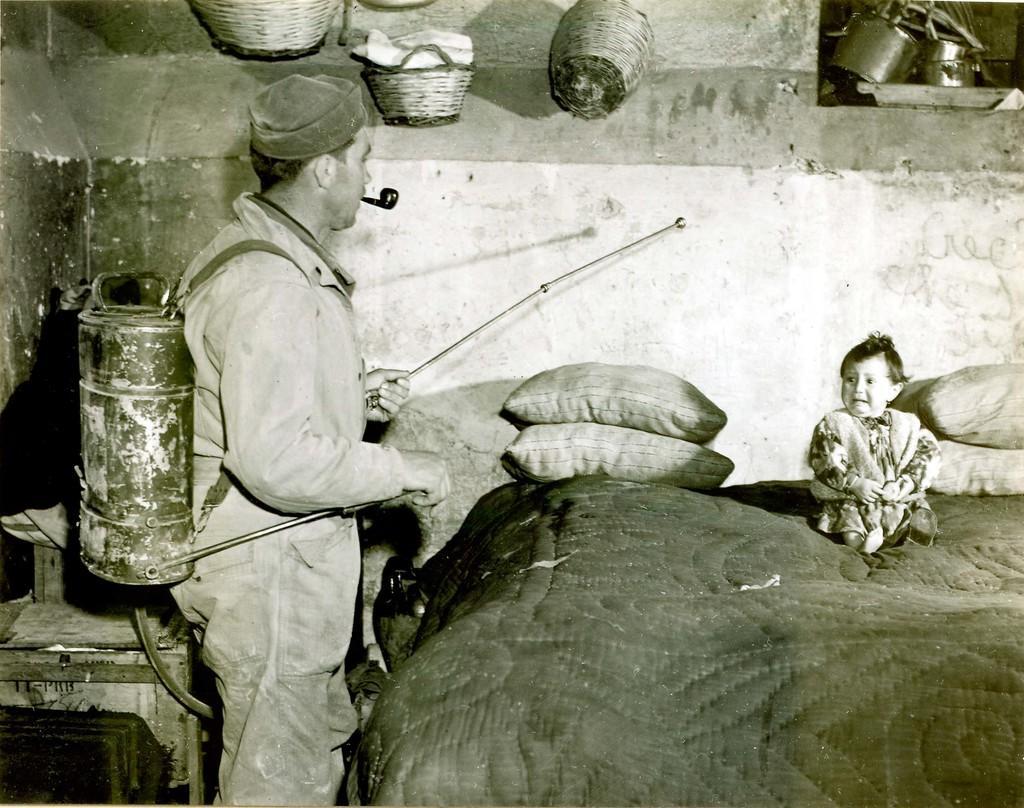Could you give a brief overview of what you see in this image? In this picture we can see a baby sitting on a bed, one person holding a water bag and spearing something, side we can see wall, some baskets are attached to the wall. 